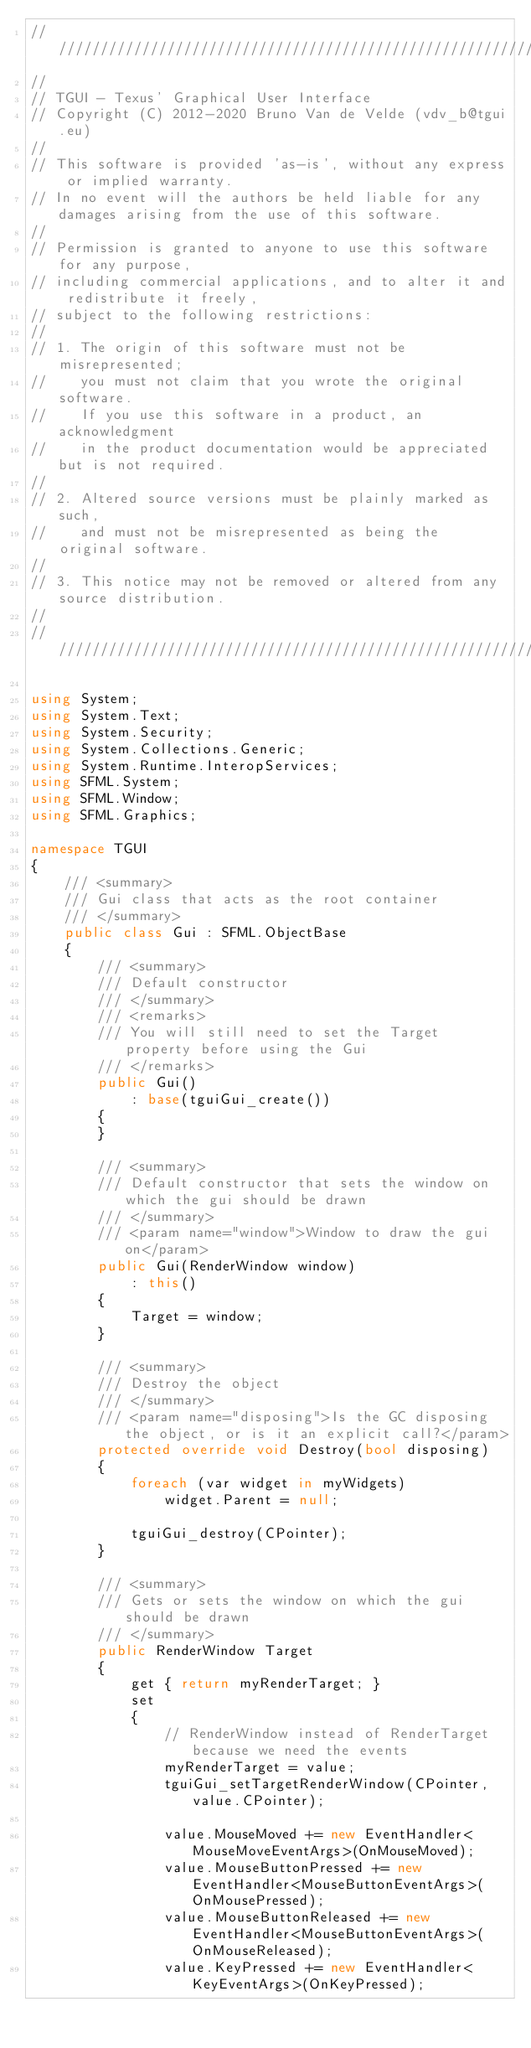<code> <loc_0><loc_0><loc_500><loc_500><_C#_>/////////////////////////////////////////////////////////////////////////////////////////////////////////////////////////////////
//
// TGUI - Texus' Graphical User Interface
// Copyright (C) 2012-2020 Bruno Van de Velde (vdv_b@tgui.eu)
//
// This software is provided 'as-is', without any express or implied warranty.
// In no event will the authors be held liable for any damages arising from the use of this software.
//
// Permission is granted to anyone to use this software for any purpose,
// including commercial applications, and to alter it and redistribute it freely,
// subject to the following restrictions:
//
// 1. The origin of this software must not be misrepresented;
//    you must not claim that you wrote the original software.
//    If you use this software in a product, an acknowledgment
//    in the product documentation would be appreciated but is not required.
//
// 2. Altered source versions must be plainly marked as such,
//    and must not be misrepresented as being the original software.
//
// 3. This notice may not be removed or altered from any source distribution.
//
/////////////////////////////////////////////////////////////////////////////////////////////////////////////////////////////////

using System;
using System.Text;
using System.Security;
using System.Collections.Generic;
using System.Runtime.InteropServices;
using SFML.System;
using SFML.Window;
using SFML.Graphics;

namespace TGUI
{
    /// <summary>
    /// Gui class that acts as the root container
    /// </summary>
    public class Gui : SFML.ObjectBase
    {
        /// <summary>
        /// Default constructor
        /// </summary>
        /// <remarks>
        /// You will still need to set the Target property before using the Gui
        /// </remarks>
        public Gui()
            : base(tguiGui_create())
        {
        }

        /// <summary>
        /// Default constructor that sets the window on which the gui should be drawn
        /// </summary>
        /// <param name="window">Window to draw the gui on</param>
        public Gui(RenderWindow window)
            : this()
        {
            Target = window;
        }

        /// <summary>
        /// Destroy the object
        /// </summary>
        /// <param name="disposing">Is the GC disposing the object, or is it an explicit call?</param>
        protected override void Destroy(bool disposing)
        {
            foreach (var widget in myWidgets)
                widget.Parent = null;

            tguiGui_destroy(CPointer);
        }

        /// <summary>
        /// Gets or sets the window on which the gui should be drawn
        /// </summary>
        public RenderWindow Target
        {
            get { return myRenderTarget; }
            set
            {
                // RenderWindow instead of RenderTarget because we need the events
                myRenderTarget = value;
                tguiGui_setTargetRenderWindow(CPointer, value.CPointer);

                value.MouseMoved += new EventHandler<MouseMoveEventArgs>(OnMouseMoved);
                value.MouseButtonPressed += new EventHandler<MouseButtonEventArgs>(OnMousePressed);
                value.MouseButtonReleased += new EventHandler<MouseButtonEventArgs>(OnMouseReleased);
                value.KeyPressed += new EventHandler<KeyEventArgs>(OnKeyPressed);</code> 